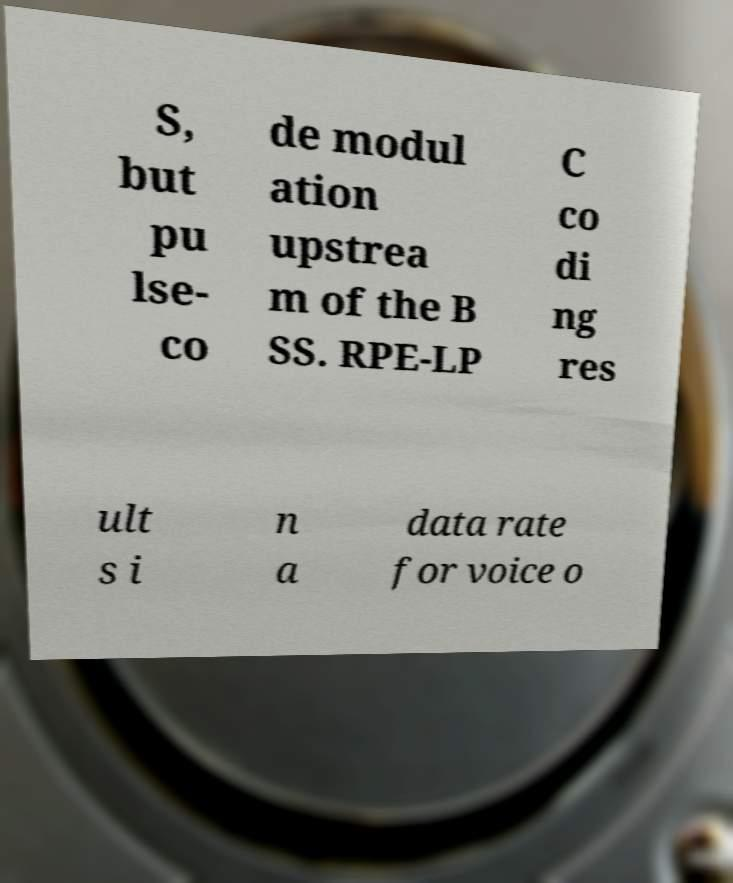Please read and relay the text visible in this image. What does it say? S, but pu lse- co de modul ation upstrea m of the B SS. RPE-LP C co di ng res ult s i n a data rate for voice o 